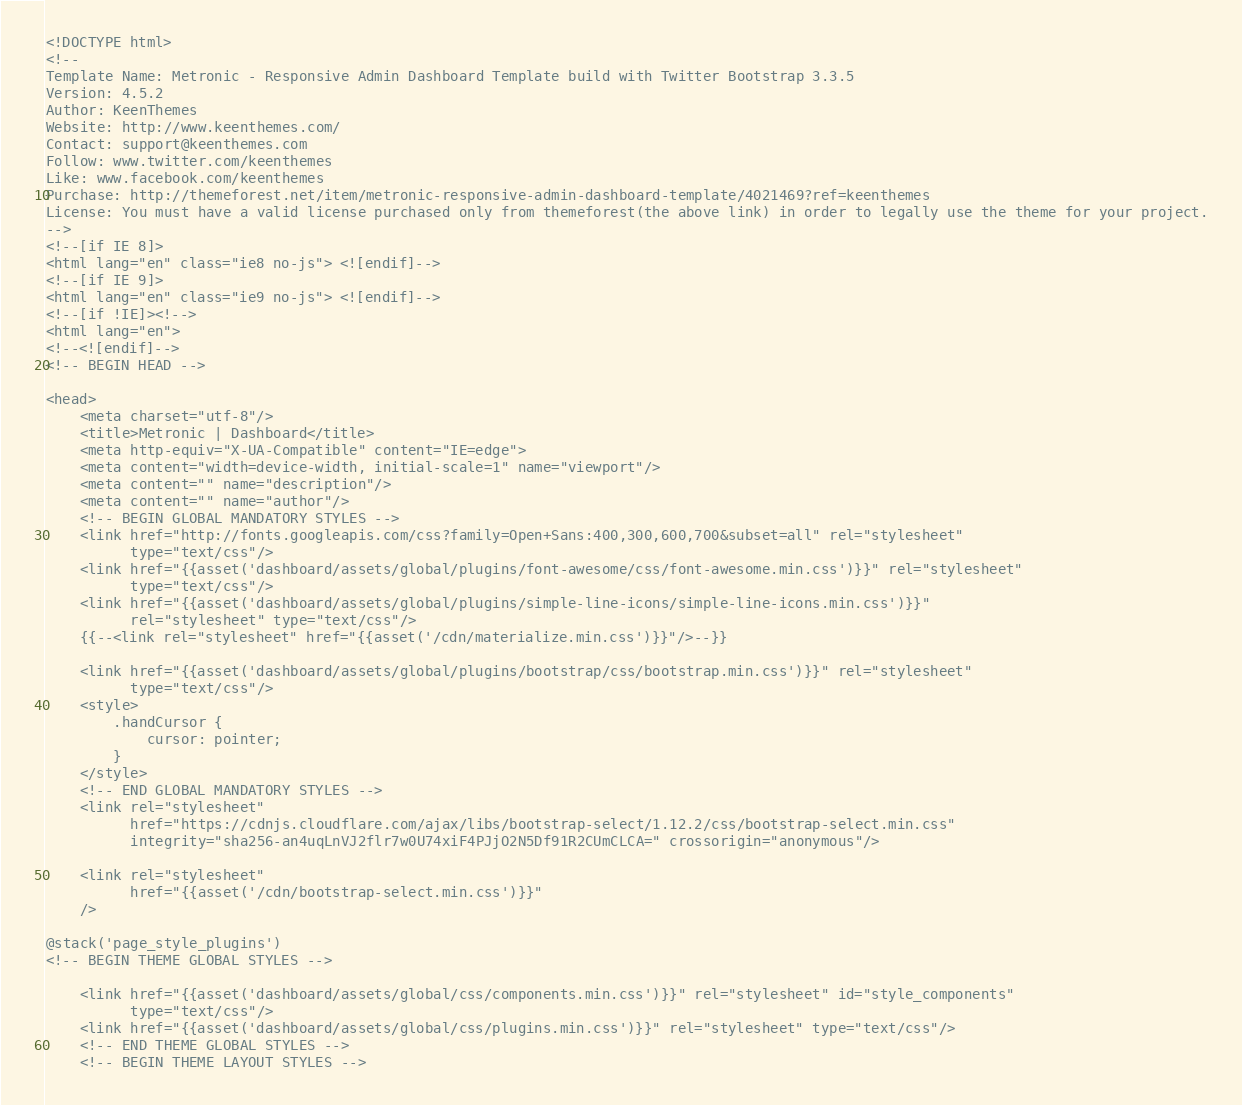Convert code to text. <code><loc_0><loc_0><loc_500><loc_500><_PHP_><!DOCTYPE html>
<!--
Template Name: Metronic - Responsive Admin Dashboard Template build with Twitter Bootstrap 3.3.5
Version: 4.5.2
Author: KeenThemes
Website: http://www.keenthemes.com/
Contact: support@keenthemes.com
Follow: www.twitter.com/keenthemes
Like: www.facebook.com/keenthemes
Purchase: http://themeforest.net/item/metronic-responsive-admin-dashboard-template/4021469?ref=keenthemes
License: You must have a valid license purchased only from themeforest(the above link) in order to legally use the theme for your project.
-->
<!--[if IE 8]>
<html lang="en" class="ie8 no-js"> <![endif]-->
<!--[if IE 9]>
<html lang="en" class="ie9 no-js"> <![endif]-->
<!--[if !IE]><!-->
<html lang="en">
<!--<![endif]-->
<!-- BEGIN HEAD -->

<head>
    <meta charset="utf-8"/>
    <title>Metronic | Dashboard</title>
    <meta http-equiv="X-UA-Compatible" content="IE=edge">
    <meta content="width=device-width, initial-scale=1" name="viewport"/>
    <meta content="" name="description"/>
    <meta content="" name="author"/>
    <!-- BEGIN GLOBAL MANDATORY STYLES -->
    <link href="http://fonts.googleapis.com/css?family=Open+Sans:400,300,600,700&subset=all" rel="stylesheet"
          type="text/css"/>
    <link href="{{asset('dashboard/assets/global/plugins/font-awesome/css/font-awesome.min.css')}}" rel="stylesheet"
          type="text/css"/>
    <link href="{{asset('dashboard/assets/global/plugins/simple-line-icons/simple-line-icons.min.css')}}"
          rel="stylesheet" type="text/css"/>
    {{--<link rel="stylesheet" href="{{asset('/cdn/materialize.min.css')}}"/>--}}

    <link href="{{asset('dashboard/assets/global/plugins/bootstrap/css/bootstrap.min.css')}}" rel="stylesheet"
          type="text/css"/>
    <style>
        .handCursor {
            cursor: pointer;
        }
    </style>
    <!-- END GLOBAL MANDATORY STYLES -->
    <link rel="stylesheet"
          href="https://cdnjs.cloudflare.com/ajax/libs/bootstrap-select/1.12.2/css/bootstrap-select.min.css"
          integrity="sha256-an4uqLnVJ2flr7w0U74xiF4PJjO2N5Df91R2CUmCLCA=" crossorigin="anonymous"/>

    <link rel="stylesheet"
          href="{{asset('/cdn/bootstrap-select.min.css')}}"
    />

@stack('page_style_plugins')
<!-- BEGIN THEME GLOBAL STYLES -->

    <link href="{{asset('dashboard/assets/global/css/components.min.css')}}" rel="stylesheet" id="style_components"
          type="text/css"/>
    <link href="{{asset('dashboard/assets/global/css/plugins.min.css')}}" rel="stylesheet" type="text/css"/>
    <!-- END THEME GLOBAL STYLES -->
    <!-- BEGIN THEME LAYOUT STYLES --></code> 